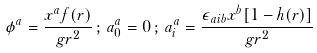<formula> <loc_0><loc_0><loc_500><loc_500>\phi ^ { a } = \frac { x ^ { a } f ( r ) } { g r ^ { 2 } } \, ; \, a ^ { a } _ { 0 } = 0 \, ; \, a ^ { a } _ { i } = \frac { \epsilon _ { a i b } x ^ { b } [ 1 - h ( r ) ] } { g r ^ { 2 } }</formula> 